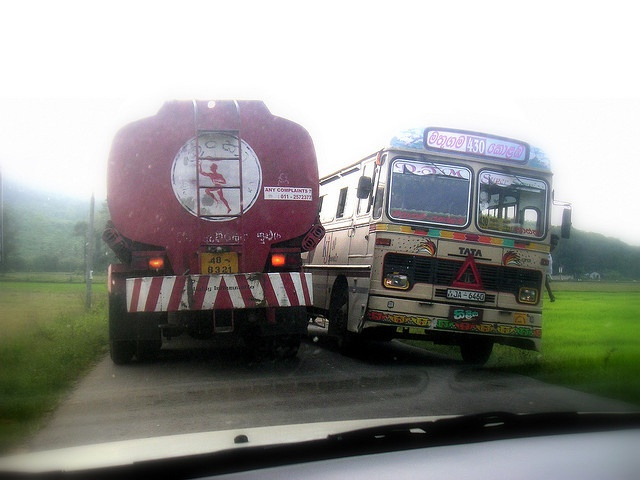Describe the objects in this image and their specific colors. I can see bus in white, black, gray, and darkgray tones and truck in white, darkgray, gray, maroon, and black tones in this image. 